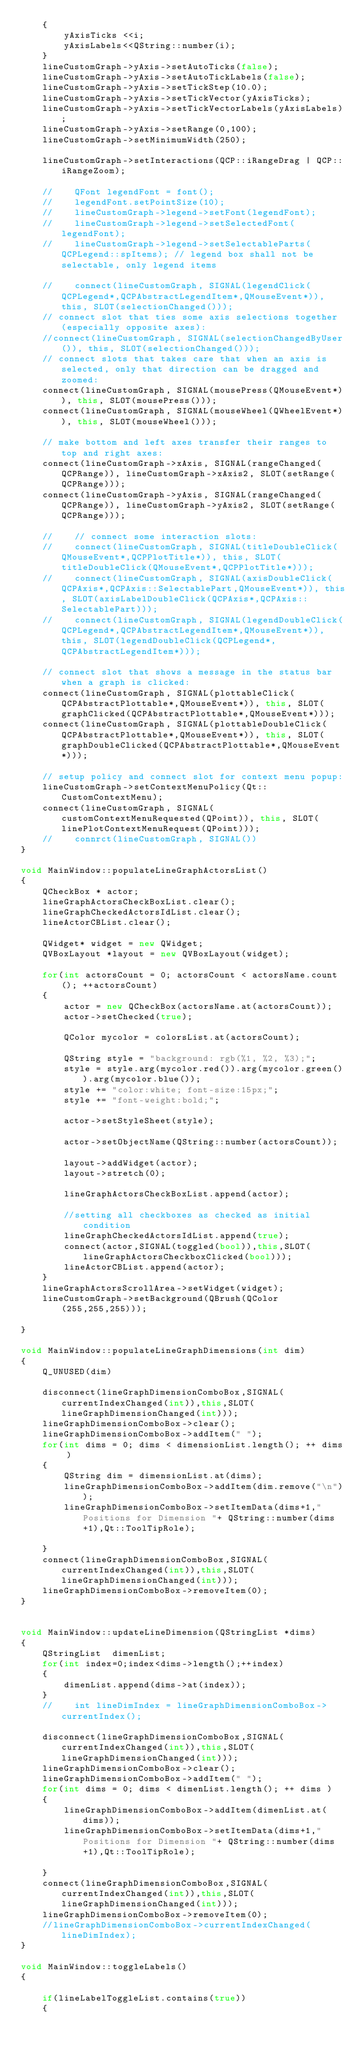Convert code to text. <code><loc_0><loc_0><loc_500><loc_500><_C++_>    {
        yAxisTicks <<i;
        yAxisLabels<<QString::number(i);
    }
    lineCustomGraph->yAxis->setAutoTicks(false);
    lineCustomGraph->yAxis->setAutoTickLabels(false);
    lineCustomGraph->yAxis->setTickStep(10.0);
    lineCustomGraph->yAxis->setTickVector(yAxisTicks);
    lineCustomGraph->yAxis->setTickVectorLabels(yAxisLabels);
    lineCustomGraph->yAxis->setRange(0,100);
    lineCustomGraph->setMinimumWidth(250);

    lineCustomGraph->setInteractions(QCP::iRangeDrag | QCP::iRangeZoom);

    //    QFont legendFont = font();
    //    legendFont.setPointSize(10);
    //    lineCustomGraph->legend->setFont(legendFont);
    //    lineCustomGraph->legend->setSelectedFont(legendFont);
    //    lineCustomGraph->legend->setSelectableParts(QCPLegend::spItems); // legend box shall not be selectable, only legend items

    //    connect(lineCustomGraph, SIGNAL(legendClick(QCPLegend*,QCPAbstractLegendItem*,QMouseEvent*)), this, SLOT(selectionChanged()));
    // connect slot that ties some axis selections together (especially opposite axes):
    //connect(lineCustomGraph, SIGNAL(selectionChangedByUser()), this, SLOT(selectionChanged()));
    // connect slots that takes care that when an axis is selected, only that direction can be dragged and zoomed:
    connect(lineCustomGraph, SIGNAL(mousePress(QMouseEvent*)), this, SLOT(mousePress()));
    connect(lineCustomGraph, SIGNAL(mouseWheel(QWheelEvent*)), this, SLOT(mouseWheel()));

    // make bottom and left axes transfer their ranges to top and right axes:
    connect(lineCustomGraph->xAxis, SIGNAL(rangeChanged(QCPRange)), lineCustomGraph->xAxis2, SLOT(setRange(QCPRange)));
    connect(lineCustomGraph->yAxis, SIGNAL(rangeChanged(QCPRange)), lineCustomGraph->yAxis2, SLOT(setRange(QCPRange)));

    //    // connect some interaction slots:
    //    connect(lineCustomGraph, SIGNAL(titleDoubleClick(QMouseEvent*,QCPPlotTitle*)), this, SLOT(titleDoubleClick(QMouseEvent*,QCPPlotTitle*)));
    //    connect(lineCustomGraph, SIGNAL(axisDoubleClick(QCPAxis*,QCPAxis::SelectablePart,QMouseEvent*)), this, SLOT(axisLabelDoubleClick(QCPAxis*,QCPAxis::SelectablePart)));
    //    connect(lineCustomGraph, SIGNAL(legendDoubleClick(QCPLegend*,QCPAbstractLegendItem*,QMouseEvent*)), this, SLOT(legendDoubleClick(QCPLegend*,QCPAbstractLegendItem*)));

    // connect slot that shows a message in the status bar when a graph is clicked:
    connect(lineCustomGraph, SIGNAL(plottableClick(QCPAbstractPlottable*,QMouseEvent*)), this, SLOT(graphClicked(QCPAbstractPlottable*,QMouseEvent*)));
    connect(lineCustomGraph, SIGNAL(plottableDoubleClick(QCPAbstractPlottable*,QMouseEvent*)), this, SLOT(graphDoubleClicked(QCPAbstractPlottable*,QMouseEvent*)));

    // setup policy and connect slot for context menu popup:
    lineCustomGraph->setContextMenuPolicy(Qt::CustomContextMenu);
    connect(lineCustomGraph, SIGNAL(customContextMenuRequested(QPoint)), this, SLOT(linePlotContextMenuRequest(QPoint)));
    //    connrct(lineCustomGraph, SIGNAL())
}

void MainWindow::populateLineGraphActorsList()
{
    QCheckBox * actor;
    lineGraphActorsCheckBoxList.clear();
    lineGraphCheckedActorsIdList.clear();
    lineActorCBList.clear();

    QWidget* widget = new QWidget;
    QVBoxLayout *layout = new QVBoxLayout(widget);

    for(int actorsCount = 0; actorsCount < actorsName.count(); ++actorsCount)
    {
        actor = new QCheckBox(actorsName.at(actorsCount));
        actor->setChecked(true);

        QColor mycolor = colorsList.at(actorsCount);

        QString style = "background: rgb(%1, %2, %3);";
        style = style.arg(mycolor.red()).arg(mycolor.green()).arg(mycolor.blue());
        style += "color:white; font-size:15px;";
        style += "font-weight:bold;";

        actor->setStyleSheet(style);

        actor->setObjectName(QString::number(actorsCount));

        layout->addWidget(actor);
        layout->stretch(0);

        lineGraphActorsCheckBoxList.append(actor);

        //setting all checkboxes as checked as initial condition
        lineGraphCheckedActorsIdList.append(true);
        connect(actor,SIGNAL(toggled(bool)),this,SLOT(lineGraphActorsCheckboxClicked(bool)));
        lineActorCBList.append(actor);
    }
    lineGraphActorsScrollArea->setWidget(widget);
    lineCustomGraph->setBackground(QBrush(QColor(255,255,255)));

}

void MainWindow::populateLineGraphDimensions(int dim)
{
    Q_UNUSED(dim)

    disconnect(lineGraphDimensionComboBox,SIGNAL(currentIndexChanged(int)),this,SLOT(lineGraphDimensionChanged(int)));
    lineGraphDimensionComboBox->clear();
    lineGraphDimensionComboBox->addItem(" ");
    for(int dims = 0; dims < dimensionList.length(); ++ dims )
    {
        QString dim = dimensionList.at(dims);
        lineGraphDimensionComboBox->addItem(dim.remove("\n"));
        lineGraphDimensionComboBox->setItemData(dims+1,"Positions for Dimension "+ QString::number(dims+1),Qt::ToolTipRole);

    }
    connect(lineGraphDimensionComboBox,SIGNAL(currentIndexChanged(int)),this,SLOT(lineGraphDimensionChanged(int)));
    lineGraphDimensionComboBox->removeItem(0);
}


void MainWindow::updateLineDimension(QStringList *dims)
{
    QStringList  dimenList;
    for(int index=0;index<dims->length();++index)
    {
        dimenList.append(dims->at(index));
    }
    //    int lineDimIndex = lineGraphDimensionComboBox->currentIndex();

    disconnect(lineGraphDimensionComboBox,SIGNAL(currentIndexChanged(int)),this,SLOT(lineGraphDimensionChanged(int)));
    lineGraphDimensionComboBox->clear();
    lineGraphDimensionComboBox->addItem(" ");
    for(int dims = 0; dims < dimenList.length(); ++ dims )
    {
        lineGraphDimensionComboBox->addItem(dimenList.at(dims));
        lineGraphDimensionComboBox->setItemData(dims+1,"Positions for Dimension "+ QString::number(dims+1),Qt::ToolTipRole);

    }
    connect(lineGraphDimensionComboBox,SIGNAL(currentIndexChanged(int)),this,SLOT(lineGraphDimensionChanged(int)));
    lineGraphDimensionComboBox->removeItem(0);
    //lineGraphDimensionComboBox->currentIndexChanged(lineDimIndex);
}

void MainWindow::toggleLabels()
{

    if(lineLabelToggleList.contains(true))
    {</code> 